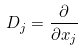Convert formula to latex. <formula><loc_0><loc_0><loc_500><loc_500>D _ { j } = \frac { \partial } { \partial x _ { j } }</formula> 